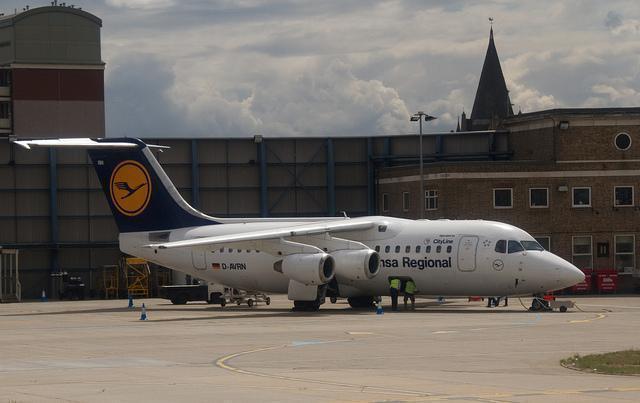What company owns this vehicle?
From the following set of four choices, select the accurate answer to respond to the question.
Options: Ford, lufthansa, gmc, ibm. Lufthansa. 